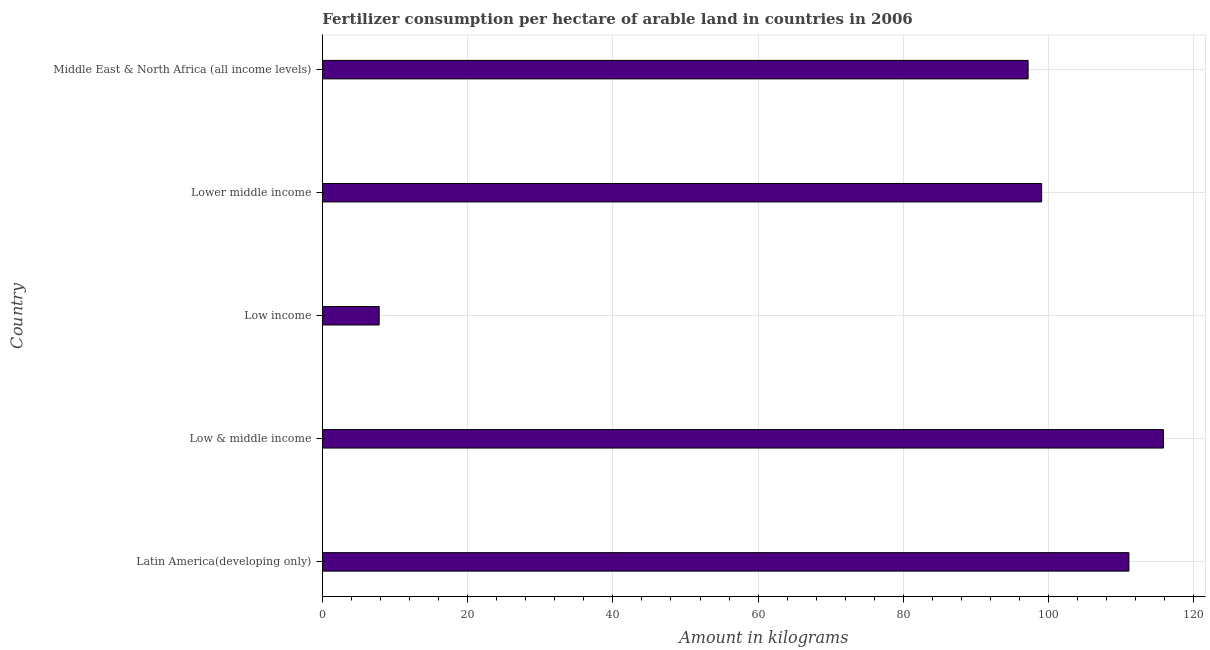Does the graph contain any zero values?
Your answer should be very brief. No. What is the title of the graph?
Ensure brevity in your answer.  Fertilizer consumption per hectare of arable land in countries in 2006 . What is the label or title of the X-axis?
Ensure brevity in your answer.  Amount in kilograms. What is the label or title of the Y-axis?
Your response must be concise. Country. What is the amount of fertilizer consumption in Low income?
Ensure brevity in your answer.  7.83. Across all countries, what is the maximum amount of fertilizer consumption?
Make the answer very short. 115.8. Across all countries, what is the minimum amount of fertilizer consumption?
Provide a short and direct response. 7.83. In which country was the amount of fertilizer consumption maximum?
Provide a succinct answer. Low & middle income. What is the sum of the amount of fertilizer consumption?
Ensure brevity in your answer.  430.88. What is the difference between the amount of fertilizer consumption in Latin America(developing only) and Middle East & North Africa (all income levels)?
Offer a terse response. 13.88. What is the average amount of fertilizer consumption per country?
Your response must be concise. 86.17. What is the median amount of fertilizer consumption?
Your answer should be compact. 99.03. What is the ratio of the amount of fertilizer consumption in Low income to that in Middle East & North Africa (all income levels)?
Your response must be concise. 0.08. Is the difference between the amount of fertilizer consumption in Latin America(developing only) and Lower middle income greater than the difference between any two countries?
Provide a succinct answer. No. What is the difference between the highest and the second highest amount of fertilizer consumption?
Give a very brief answer. 4.75. What is the difference between the highest and the lowest amount of fertilizer consumption?
Provide a succinct answer. 107.97. In how many countries, is the amount of fertilizer consumption greater than the average amount of fertilizer consumption taken over all countries?
Your answer should be compact. 4. How many bars are there?
Offer a very short reply. 5. Are all the bars in the graph horizontal?
Offer a terse response. Yes. What is the Amount in kilograms in Latin America(developing only)?
Ensure brevity in your answer.  111.05. What is the Amount in kilograms in Low & middle income?
Keep it short and to the point. 115.8. What is the Amount in kilograms in Low income?
Offer a terse response. 7.83. What is the Amount in kilograms of Lower middle income?
Provide a succinct answer. 99.03. What is the Amount in kilograms in Middle East & North Africa (all income levels)?
Make the answer very short. 97.17. What is the difference between the Amount in kilograms in Latin America(developing only) and Low & middle income?
Make the answer very short. -4.75. What is the difference between the Amount in kilograms in Latin America(developing only) and Low income?
Your answer should be compact. 103.22. What is the difference between the Amount in kilograms in Latin America(developing only) and Lower middle income?
Make the answer very short. 12.02. What is the difference between the Amount in kilograms in Latin America(developing only) and Middle East & North Africa (all income levels)?
Provide a succinct answer. 13.88. What is the difference between the Amount in kilograms in Low & middle income and Low income?
Give a very brief answer. 107.97. What is the difference between the Amount in kilograms in Low & middle income and Lower middle income?
Ensure brevity in your answer.  16.77. What is the difference between the Amount in kilograms in Low & middle income and Middle East & North Africa (all income levels)?
Make the answer very short. 18.63. What is the difference between the Amount in kilograms in Low income and Lower middle income?
Provide a short and direct response. -91.21. What is the difference between the Amount in kilograms in Low income and Middle East & North Africa (all income levels)?
Ensure brevity in your answer.  -89.34. What is the difference between the Amount in kilograms in Lower middle income and Middle East & North Africa (all income levels)?
Offer a terse response. 1.87. What is the ratio of the Amount in kilograms in Latin America(developing only) to that in Low & middle income?
Provide a succinct answer. 0.96. What is the ratio of the Amount in kilograms in Latin America(developing only) to that in Low income?
Keep it short and to the point. 14.19. What is the ratio of the Amount in kilograms in Latin America(developing only) to that in Lower middle income?
Your answer should be very brief. 1.12. What is the ratio of the Amount in kilograms in Latin America(developing only) to that in Middle East & North Africa (all income levels)?
Offer a very short reply. 1.14. What is the ratio of the Amount in kilograms in Low & middle income to that in Low income?
Your answer should be very brief. 14.79. What is the ratio of the Amount in kilograms in Low & middle income to that in Lower middle income?
Your response must be concise. 1.17. What is the ratio of the Amount in kilograms in Low & middle income to that in Middle East & North Africa (all income levels)?
Make the answer very short. 1.19. What is the ratio of the Amount in kilograms in Low income to that in Lower middle income?
Offer a terse response. 0.08. What is the ratio of the Amount in kilograms in Low income to that in Middle East & North Africa (all income levels)?
Keep it short and to the point. 0.08. What is the ratio of the Amount in kilograms in Lower middle income to that in Middle East & North Africa (all income levels)?
Keep it short and to the point. 1.02. 